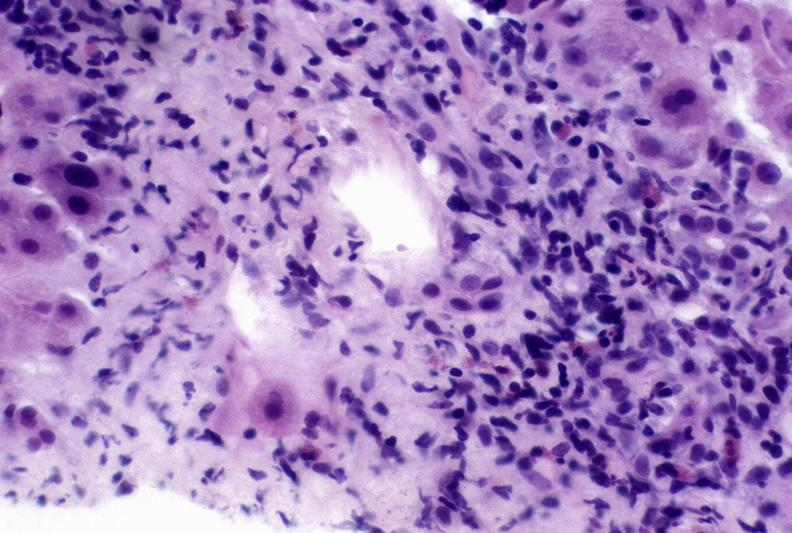what is present?
Answer the question using a single word or phrase. Hepatobiliary 